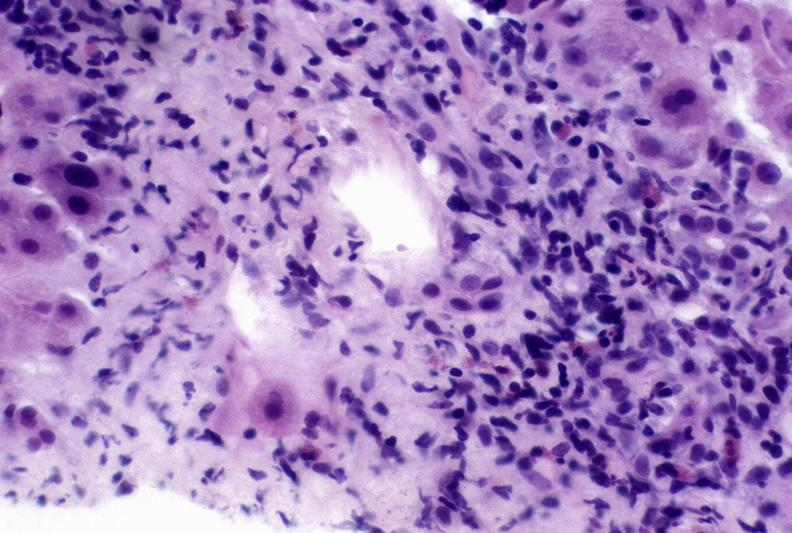what is present?
Answer the question using a single word or phrase. Hepatobiliary 